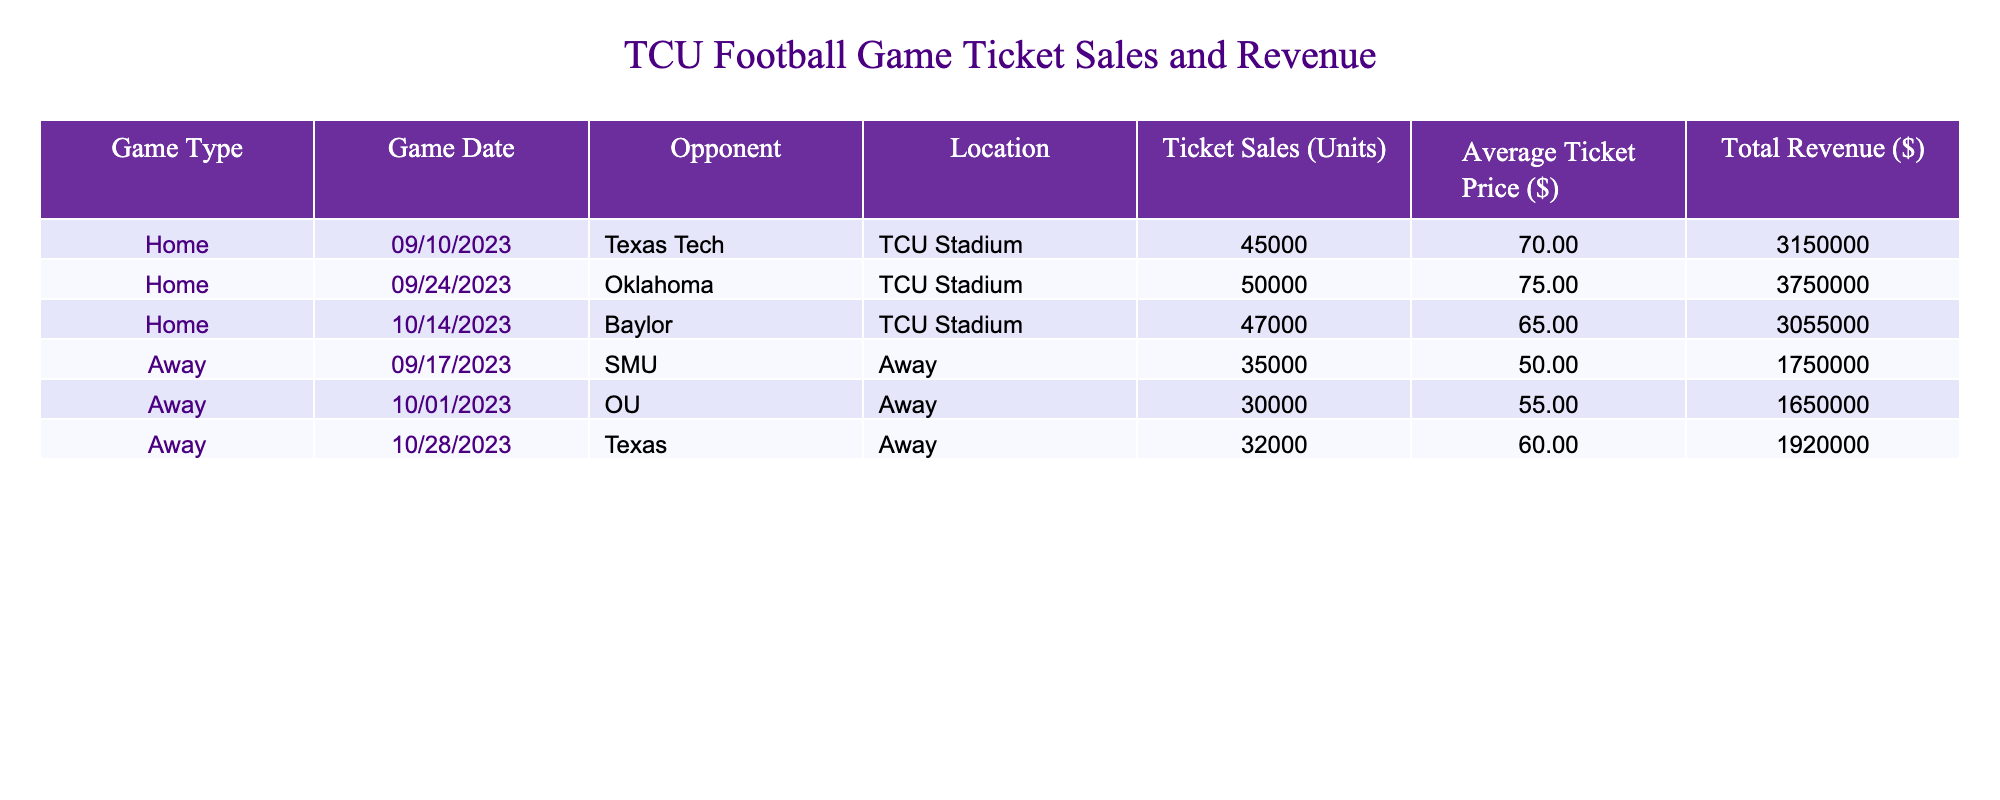What was the total revenue generated from TCU home games? To find the total revenue from home games, we look at the rows labeled "Home" and sum the Total Revenue values: 3,150,000 (Texas Tech) + 3,750,000 (Oklahoma) + 3,055,000 (Baylor) = 9,955,000.
Answer: 9,955,000 How many units were sold for the away game against Texas? In the row corresponding to the away game against Texas, the Ticket Sales (Units) value is 32,000.
Answer: 32,000 What is the average ticket price for TCU home games? We take the average of the Average Ticket Price values for home games: (70 + 75 + 65) / 3 = 70.
Answer: 70 Did TCU generate more revenue from home games compared to away games? Total revenue from home games is 9,955,000, and for away games, it is 1,750,000 (SMU) + 1,650,000 (OU) + 1,920,000 (Texas) = 5,320,000. Since 9,955,000 > 5,320,000, the answer is yes.
Answer: Yes What is the difference in total revenue between the home game against Oklahoma and the away game against SMU? The total revenue from the home game against Oklahoma is 3,750,000, while for the away game against SMU, it is 1,750,000. The difference is 3,750,000 - 1,750,000 = 2,000,000.
Answer: 2,000,000 How many more units were sold in the home game against Texas Tech compared to the away game against OU? Home game against Texas Tech had 45,000 units sold, while for OU away game, there were 30,000 units sold. The difference is 45,000 - 30,000 = 15,000.
Answer: 15,000 What was the lowest average ticket price among all games? We examine the Average Ticket Price column and find the prices: 70 (Texas Tech), 75 (Oklahoma), 65 (Baylor), 50 (SMU), 55 (OU), and 60 (Texas). The lowest price is 50 from the away game against SMU.
Answer: 50 Which opponent had the highest ticket sales in a home game? Looking through the home games, the ticket sales figures are: 45,000 (Texas Tech), 50,000 (Oklahoma), and 47,000 (Baylor). The highest is 50,000 for Oklahoma.
Answer: Oklahoma 